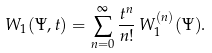<formula> <loc_0><loc_0><loc_500><loc_500>W _ { 1 } ( \Psi , t ) = \sum _ { n = 0 } ^ { \infty } \frac { t ^ { n } } { n ! } \, W _ { 1 } ^ { ( n ) } ( \Psi ) .</formula> 